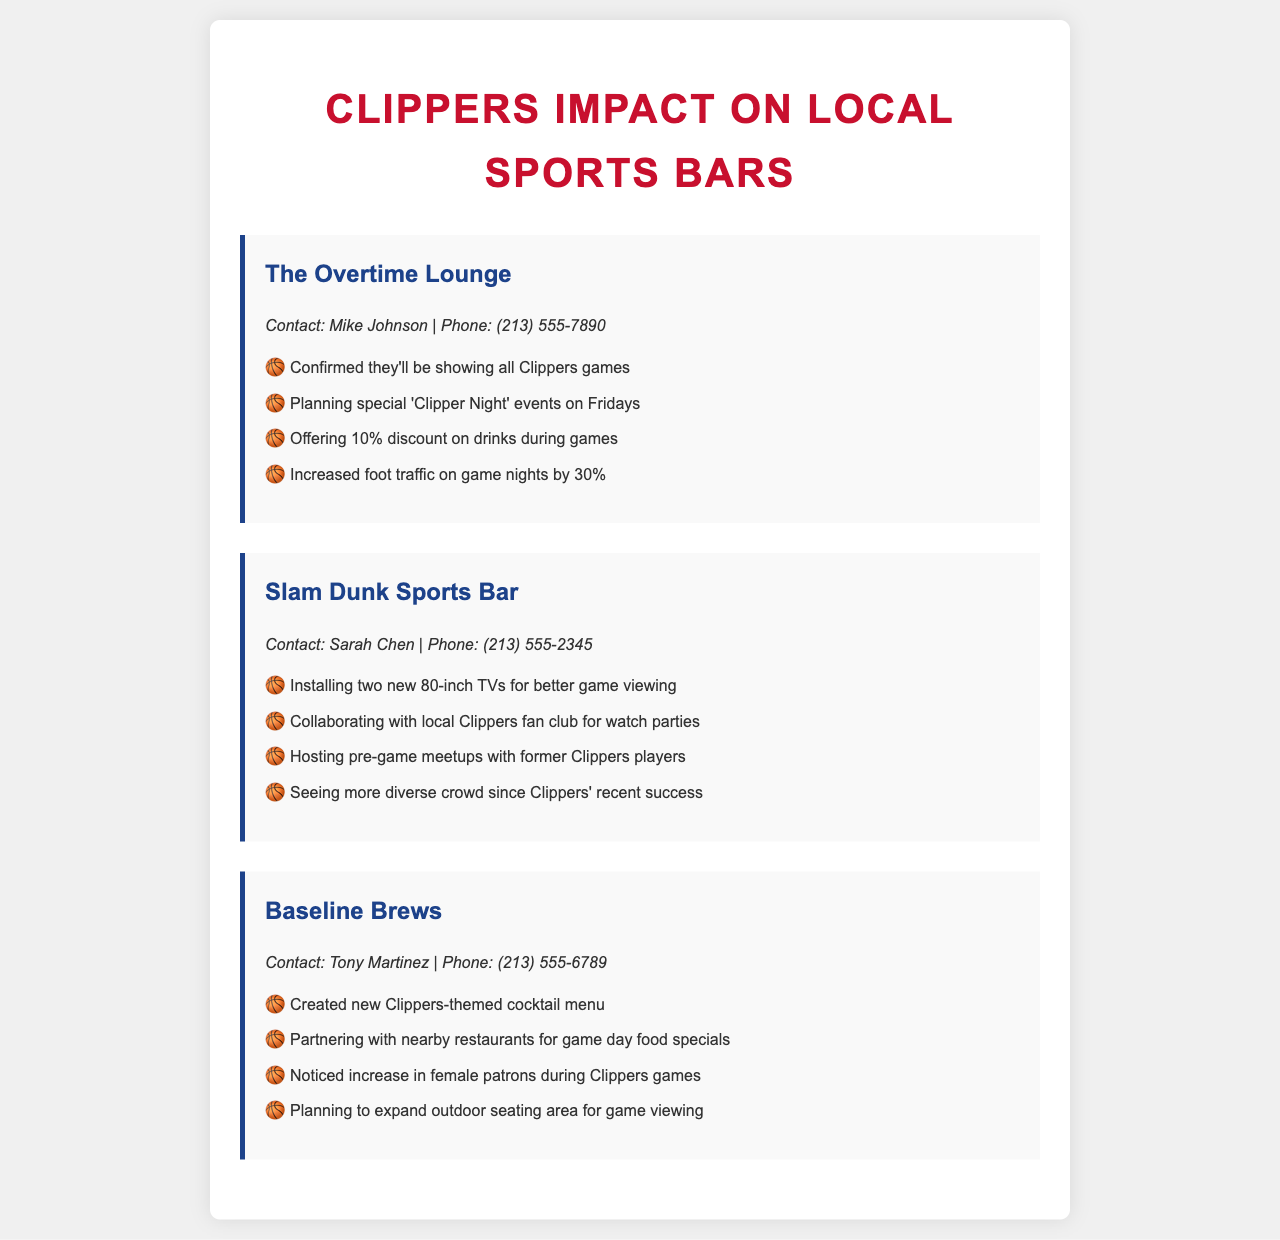What is the name of the first bar listed? The name of the first bar is found at the top of the first bar record in the document.
Answer: The Overtime Lounge Who is the contact person for Slam Dunk Sports Bar? The contact person is mentioned in the contact info section under Slam Dunk Sports Bar.
Answer: Sarah Chen What percentage discount on drinks does The Overtime Lounge offer during games? The discount percentage is noted in the bullet points under The Overtime Lounge.
Answer: 10% Which bar is planning a Clipper Night event? The bar with the event plans is identified in the list of offerings of that establishment.
Answer: The Overtime Lounge How much has foot traffic increased on game nights at The Overtime Lounge? This figure is provided in the bullet points of that bar's record.
Answer: 30% What new feature is Slam Dunk Sports Bar installing for game viewing? The specific feature being installed is highlighted in product offerings.
Answer: Two new 80-inch TVs Which bar is creating a Clippers-themed cocktail menu? The bar that is associated with the themed menu can be found in the corresponding list entry.
Answer: Baseline Brews What type of crowd has Slam Dunk Sports Bar seen since the Clippers' recent success? The change in crowd demographics is indicated in the bar's description.
Answer: More diverse crowd What is Baseline Brews planning to expand for game viewing? The expansion plan is stated in one of the bullet points regarding improvements for game nights.
Answer: Outdoor seating area 